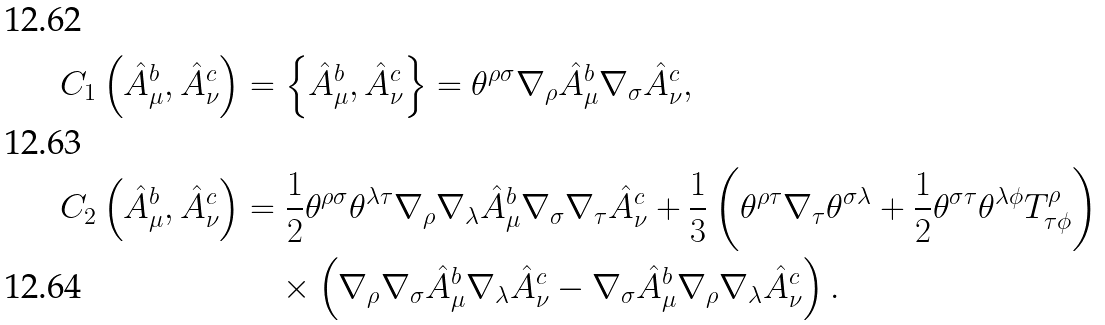Convert formula to latex. <formula><loc_0><loc_0><loc_500><loc_500>C _ { 1 } \left ( \hat { A } ^ { b } _ { \mu } , \hat { A } ^ { c } _ { \nu } \right ) & = \left \{ \hat { A } ^ { b } _ { \mu } , \hat { A } ^ { c } _ { \nu } \right \} = \theta ^ { \rho \sigma } \nabla _ { \rho } \hat { A } ^ { b } _ { \mu } \nabla _ { \sigma } \hat { A } ^ { c } _ { \nu } , \\ C _ { 2 } \left ( \hat { A } ^ { b } _ { \mu } , \hat { A } ^ { c } _ { \nu } \right ) & = \frac { 1 } { 2 } \theta ^ { \rho \sigma } \theta ^ { \lambda \tau } \nabla _ { \rho } \nabla _ { \lambda } \hat { A } ^ { b } _ { \mu } \nabla _ { \sigma } \nabla _ { \tau } \hat { A } ^ { c } _ { \nu } + \frac { 1 } { 3 } \left ( \theta ^ { \rho \tau } \nabla _ { \tau } \theta ^ { \sigma \lambda } + \frac { 1 } { 2 } \theta ^ { \sigma \tau } \theta ^ { \lambda \phi } T ^ { \rho } _ { \tau \phi } \right ) \\ & \quad \times \left ( \nabla _ { \rho } \nabla _ { \sigma } \hat { A } ^ { b } _ { \mu } \nabla _ { \lambda } \hat { A } ^ { c } _ { \nu } - \nabla _ { \sigma } \hat { A } ^ { b } _ { \mu } \nabla _ { \rho } \nabla _ { \lambda } \hat { A } ^ { c } _ { \nu } \right ) .</formula> 